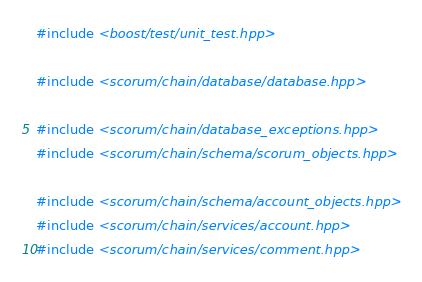<code> <loc_0><loc_0><loc_500><loc_500><_C++_>#include <boost/test/unit_test.hpp>

#include <scorum/chain/database/database.hpp>

#include <scorum/chain/database_exceptions.hpp>
#include <scorum/chain/schema/scorum_objects.hpp>

#include <scorum/chain/schema/account_objects.hpp>
#include <scorum/chain/services/account.hpp>
#include <scorum/chain/services/comment.hpp></code> 